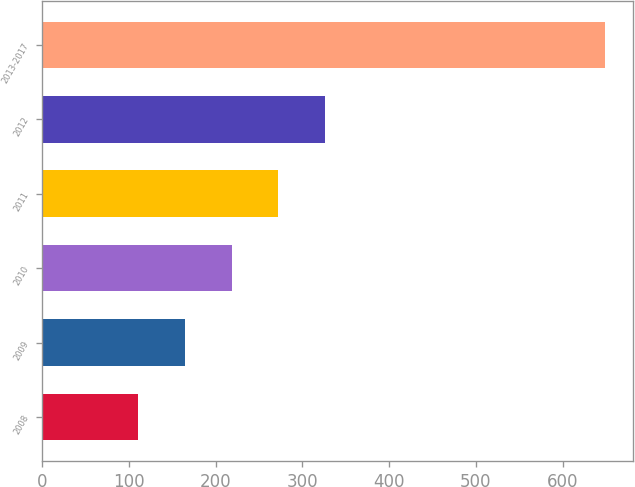<chart> <loc_0><loc_0><loc_500><loc_500><bar_chart><fcel>2008<fcel>2009<fcel>2010<fcel>2011<fcel>2012<fcel>2013-2017<nl><fcel>111.2<fcel>164.89<fcel>218.58<fcel>272.27<fcel>325.96<fcel>648.1<nl></chart> 